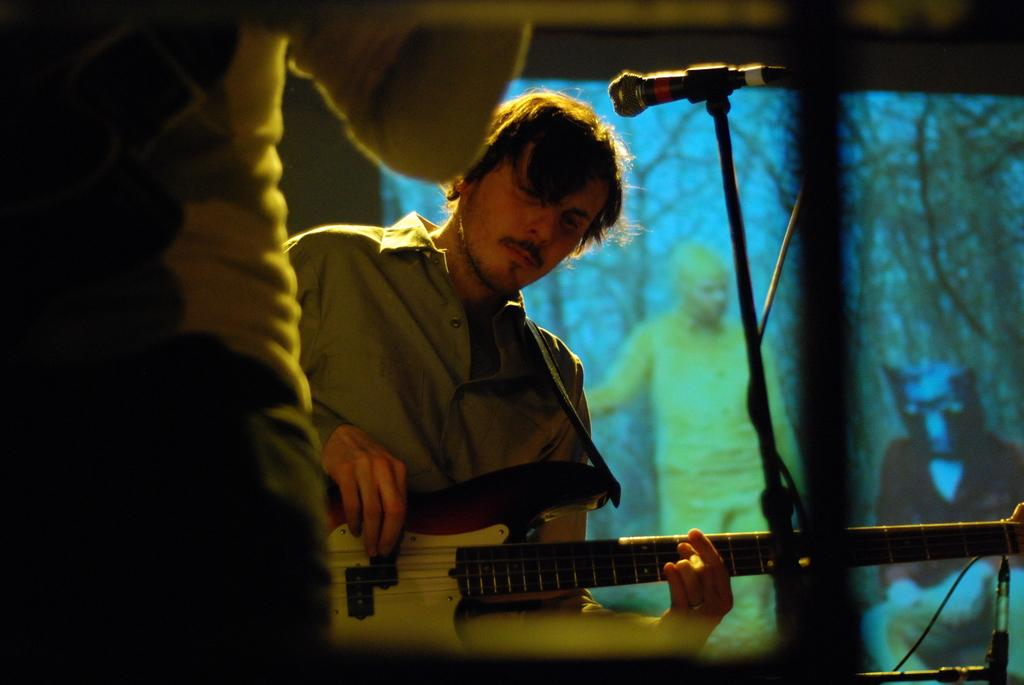What is the man in the image doing? The man is playing a guitar. What object is associated with the man's activity? There is a microphone (mike) in the image. What can be seen in the background of the image? There is a screen and two people in the background of the image. What is the name of the person who approved the mark on the guitar in the image? There is no mention of an approval or mark on the guitar in the image. 